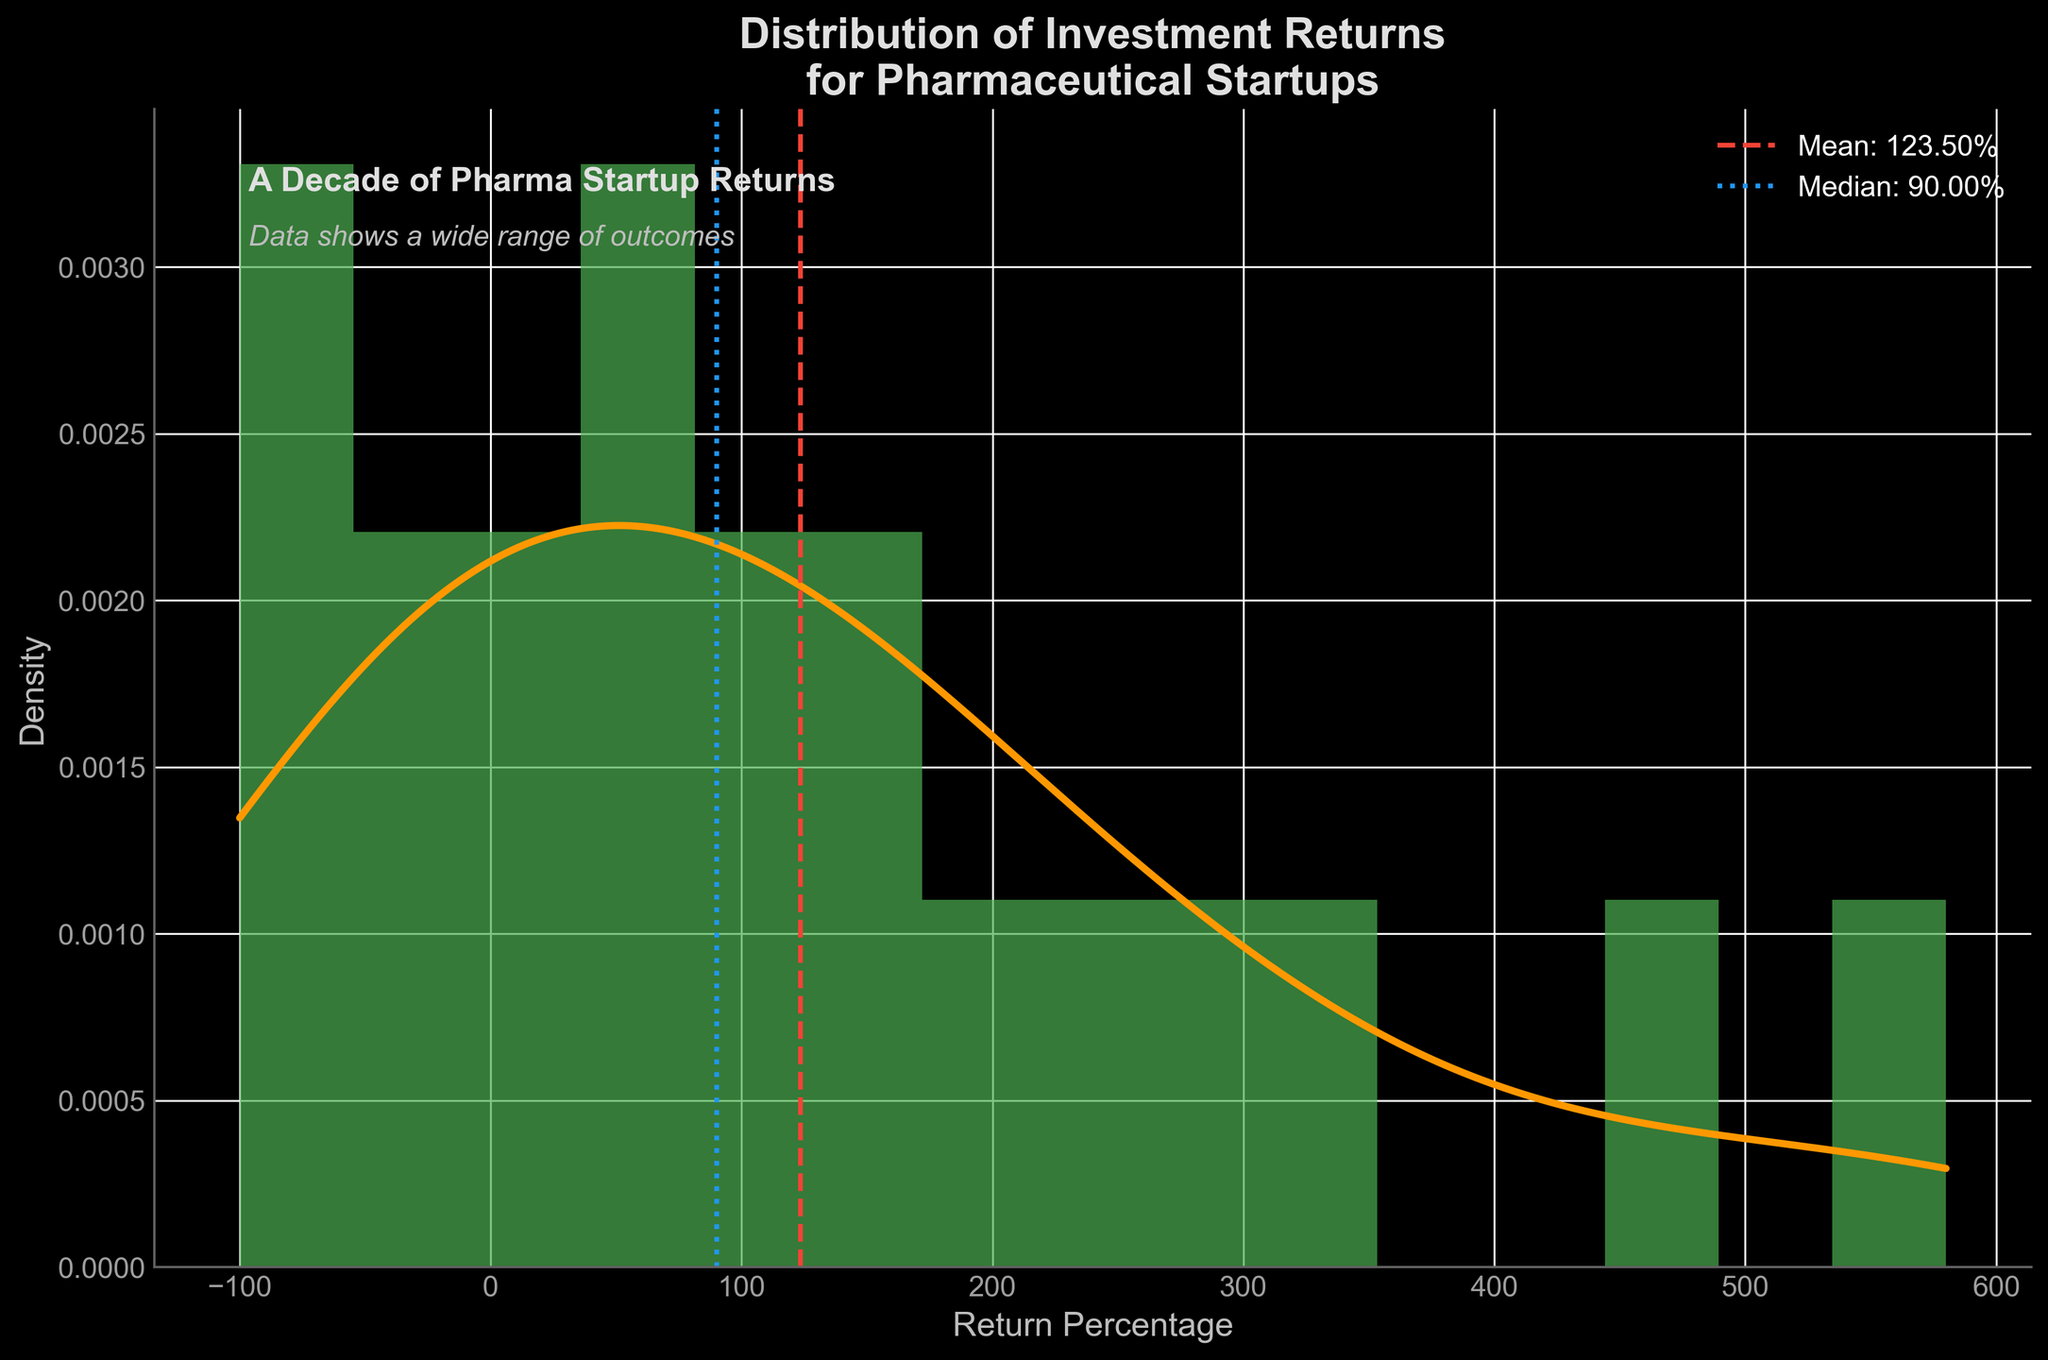What is the title of the figure? The title is shown at the top of the figure, stating "Distribution of Investment Returns for Pharmaceutical Startups".
Answer: Distribution of Investment Returns for Pharmaceutical Startups What is the color of the KDE curve? The KDE curve is the smooth line over the histogram, and it is colored orange.
Answer: Orange What is the mean return percentage of the pharmaceutical startups? The mean return percentage is indicated by a vertical dashed red line, with a label reading "Mean: 100.50%" on the figure.
Answer: 100.50% What is the median return percentage? The median return percentage is shown with a vertical blue dotted line, labelled "Median: 80.00%" on the figure.
Answer: 80.00% What is the range of the investment returns displayed on the x-axis? The x-axis ranges from the minimum investment return percentage to the maximum, as shown from -100 to 580.
Answer: -100 to 580 How many negative return data points are there? The histogram bars indicate that 5 data points fall below 0%, which are -100, -80, -60, -40, and -20.
Answer: 5 Which startup had the highest investment return, and what was it? Referring to the data provided for context, Moderna had the highest return at 580%.
Answer: Moderna, 580% How does the median return percentage compare to the mean return percentage? The figure shows two lines: the red dashed line (mean) at 100.50% and the blue dotted line (median) at 80.00%. The median is less than the mean.
Answer: Median < Mean What observation can be made about the density near the mean return? The KDE curve peaks above the mean return percentage around 100, suggesting higher density in this region.
Answer: High density near mean How are the axes labeled in the figure? The x-axis is labeled "Return Percentage" and the y-axis is labeled "Density".
Answer: Return Percentage, Density 